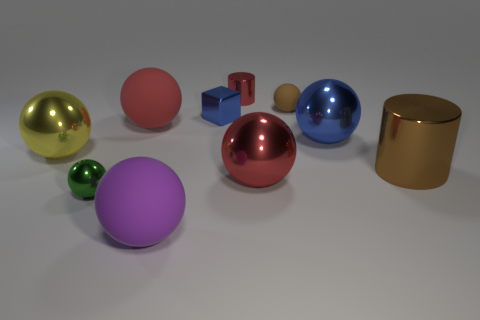What number of other blue blocks have the same size as the cube? There are no other blue blocks present that match the size of the specific blue cube in the image. 